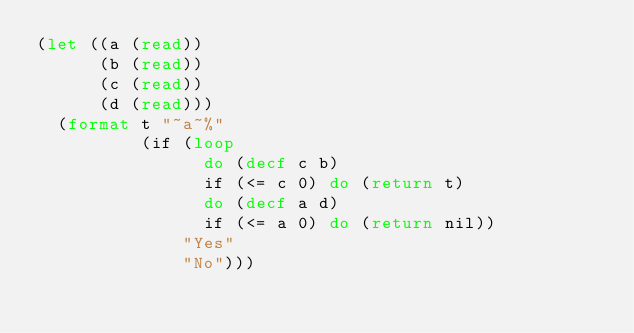<code> <loc_0><loc_0><loc_500><loc_500><_Lisp_>(let ((a (read))
      (b (read))
      (c (read))
      (d (read)))
  (format t "~a~%"
          (if (loop
                do (decf c b)
                if (<= c 0) do (return t)
                do (decf a d)
                if (<= a 0) do (return nil))
              "Yes"
              "No")))

</code> 